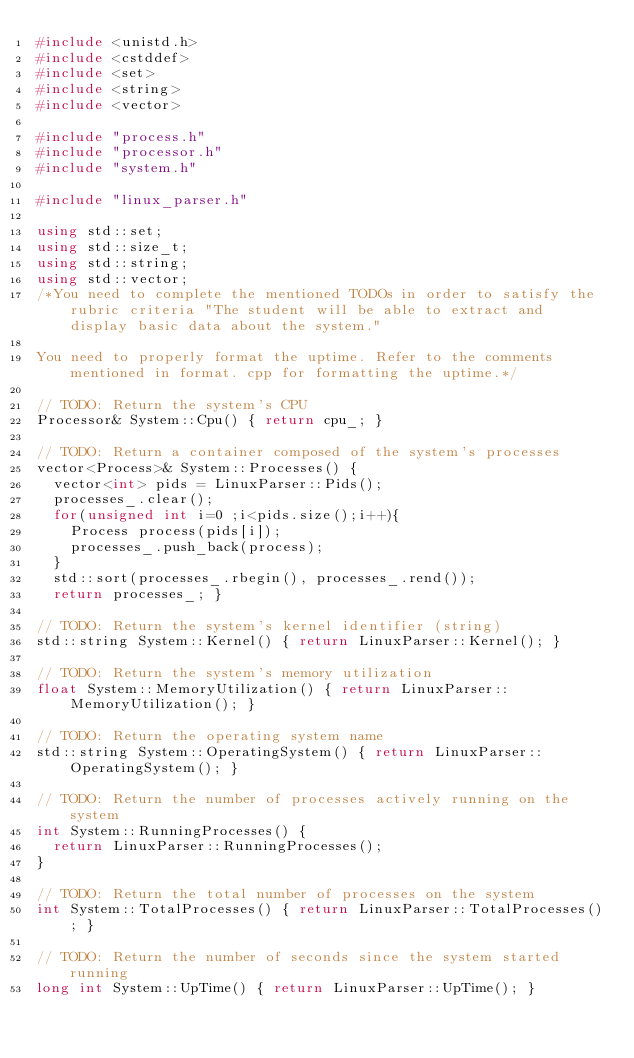Convert code to text. <code><loc_0><loc_0><loc_500><loc_500><_C++_>#include <unistd.h>
#include <cstddef>
#include <set>
#include <string>
#include <vector>

#include "process.h"
#include "processor.h"
#include "system.h"

#include "linux_parser.h"

using std::set;
using std::size_t;
using std::string;
using std::vector;
/*You need to complete the mentioned TODOs in order to satisfy the rubric criteria "The student will be able to extract and display basic data about the system."

You need to properly format the uptime. Refer to the comments mentioned in format. cpp for formatting the uptime.*/

// TODO: Return the system's CPU
Processor& System::Cpu() { return cpu_; }

// TODO: Return a container composed of the system's processes
vector<Process>& System::Processes() { 
  vector<int> pids = LinuxParser::Pids();
  processes_.clear();
  for(unsigned int i=0 ;i<pids.size();i++){
    Process process(pids[i]);
    processes_.push_back(process);
  }
  std::sort(processes_.rbegin(), processes_.rend());
  return processes_; }

// TODO: Return the system's kernel identifier (string)
std::string System::Kernel() { return LinuxParser::Kernel(); }

// TODO: Return the system's memory utilization
float System::MemoryUtilization() { return LinuxParser::MemoryUtilization(); }

// TODO: Return the operating system name
std::string System::OperatingSystem() { return LinuxParser::OperatingSystem(); }

// TODO: Return the number of processes actively running on the system
int System::RunningProcesses() { 
  return LinuxParser::RunningProcesses();
}

// TODO: Return the total number of processes on the system
int System::TotalProcesses() { return LinuxParser::TotalProcesses(); }

// TODO: Return the number of seconds since the system started running
long int System::UpTime() { return LinuxParser::UpTime(); }
</code> 